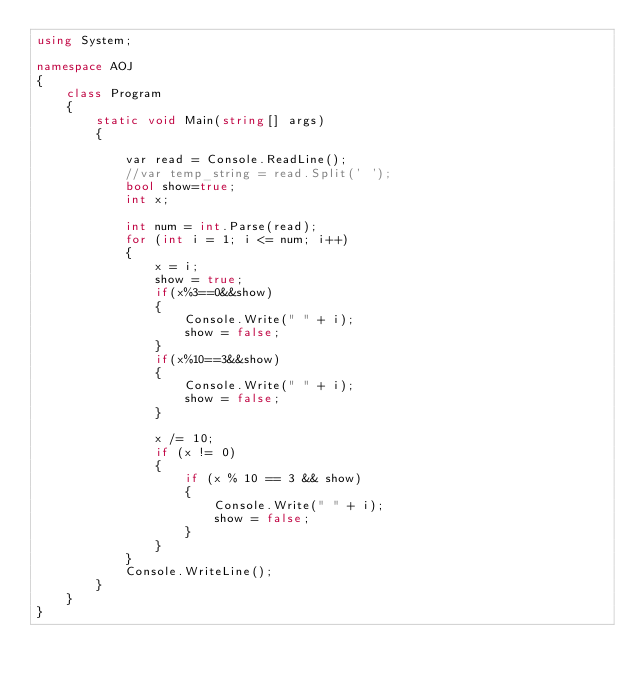Convert code to text. <code><loc_0><loc_0><loc_500><loc_500><_C#_>using System;

namespace AOJ
{
    class Program
    {
        static void Main(string[] args)
        {

            var read = Console.ReadLine();
            //var temp_string = read.Split(' ');
            bool show=true;
            int x;

            int num = int.Parse(read);
            for (int i = 1; i <= num; i++)
            {
                x = i;
                show = true;
                if(x%3==0&&show)
                {
                    Console.Write(" " + i);
                    show = false;
                }
                if(x%10==3&&show)
                {
                    Console.Write(" " + i);
                    show = false;
                }

                x /= 10;
                if (x != 0)
                {
                    if (x % 10 == 3 && show)
                    {
                        Console.Write(" " + i);
                        show = false;
                    }
                }
            }
            Console.WriteLine();
        }
    }
}</code> 